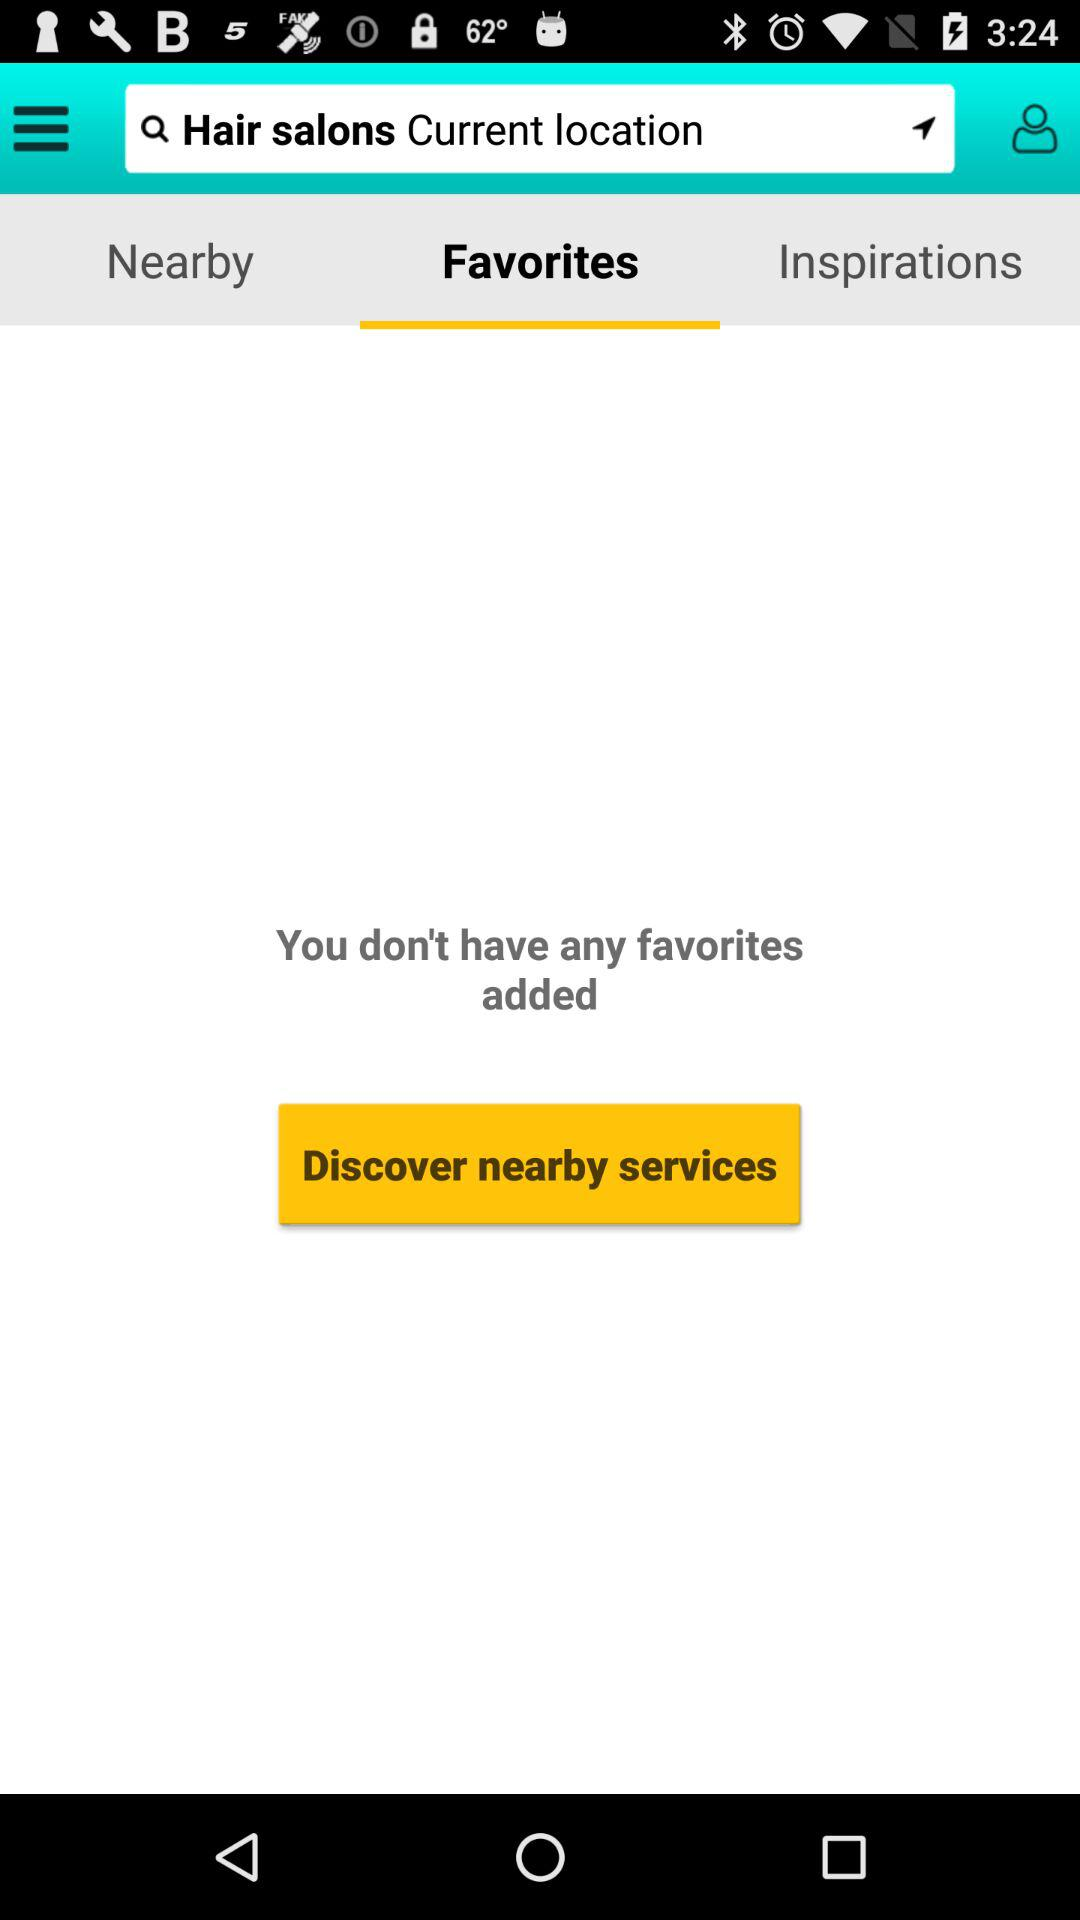Are there any added favorites? You don't have any added favorites. 